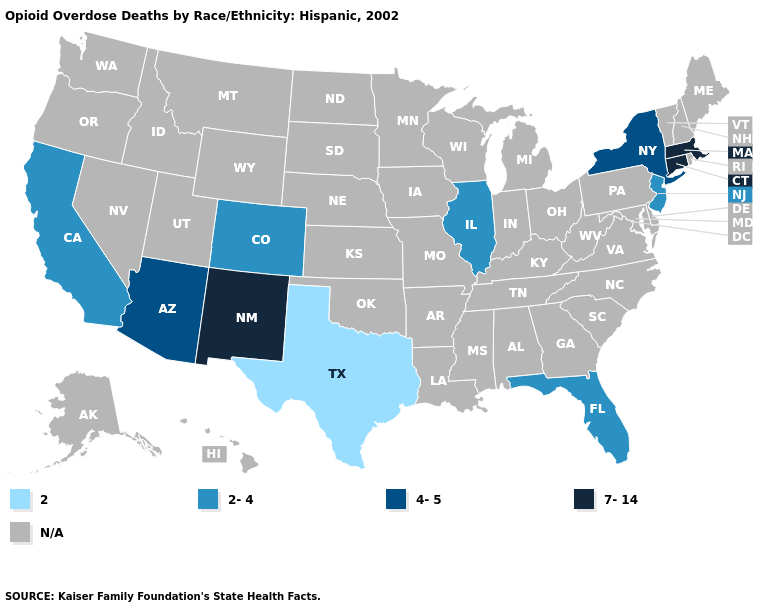Does Florida have the lowest value in the South?
Give a very brief answer. No. What is the value of Utah?
Keep it brief. N/A. Does New Jersey have the highest value in the Northeast?
Give a very brief answer. No. Which states have the lowest value in the USA?
Be succinct. Texas. What is the lowest value in the West?
Write a very short answer. 2-4. What is the value of West Virginia?
Write a very short answer. N/A. What is the highest value in the USA?
Be succinct. 7-14. What is the highest value in the USA?
Keep it brief. 7-14. What is the value of Maryland?
Be succinct. N/A. What is the highest value in states that border Missouri?
Answer briefly. 2-4. What is the highest value in the West ?
Write a very short answer. 7-14. Name the states that have a value in the range 4-5?
Short answer required. Arizona, New York. What is the highest value in the MidWest ?
Short answer required. 2-4. 